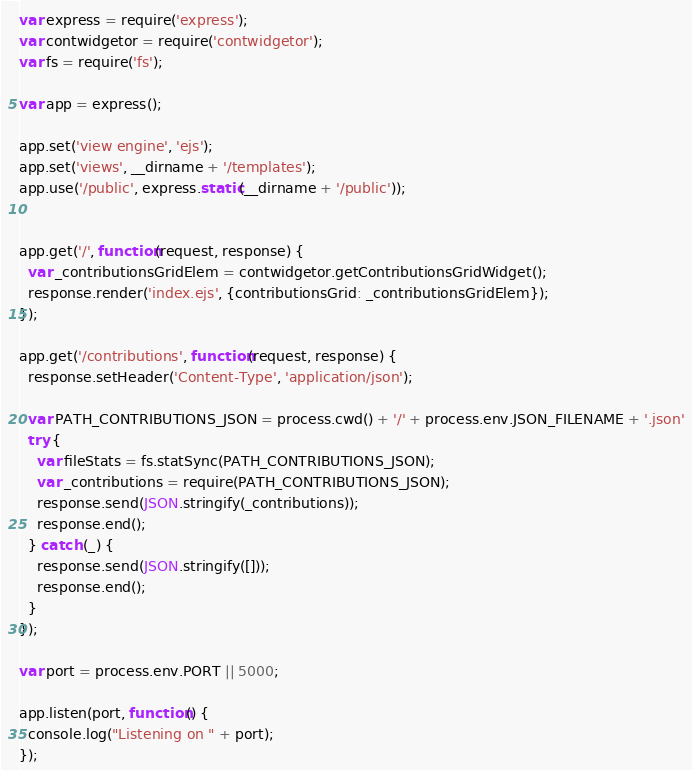Convert code to text. <code><loc_0><loc_0><loc_500><loc_500><_JavaScript_>var express = require('express');
var contwidgetor = require('contwidgetor');
var fs = require('fs');

var app = express();

app.set('view engine', 'ejs');
app.set('views', __dirname + '/templates');
app.use('/public', express.static(__dirname + '/public'));


app.get('/', function(request, response) {
  var _contributionsGridElem = contwidgetor.getContributionsGridWidget();
  response.render('index.ejs', {contributionsGrid: _contributionsGridElem});
});

app.get('/contributions', function(request, response) {
  response.setHeader('Content-Type', 'application/json');

  var PATH_CONTRIBUTIONS_JSON = process.cwd() + '/' + process.env.JSON_FILENAME + '.json'
  try {
    var fileStats = fs.statSync(PATH_CONTRIBUTIONS_JSON);
    var _contributions = require(PATH_CONTRIBUTIONS_JSON);
    response.send(JSON.stringify(_contributions));
    response.end();
  } catch (_) {
    response.send(JSON.stringify([]));
    response.end();
  }
});

var port = process.env.PORT || 5000;

app.listen(port, function() {
  console.log("Listening on " + port);
});
</code> 